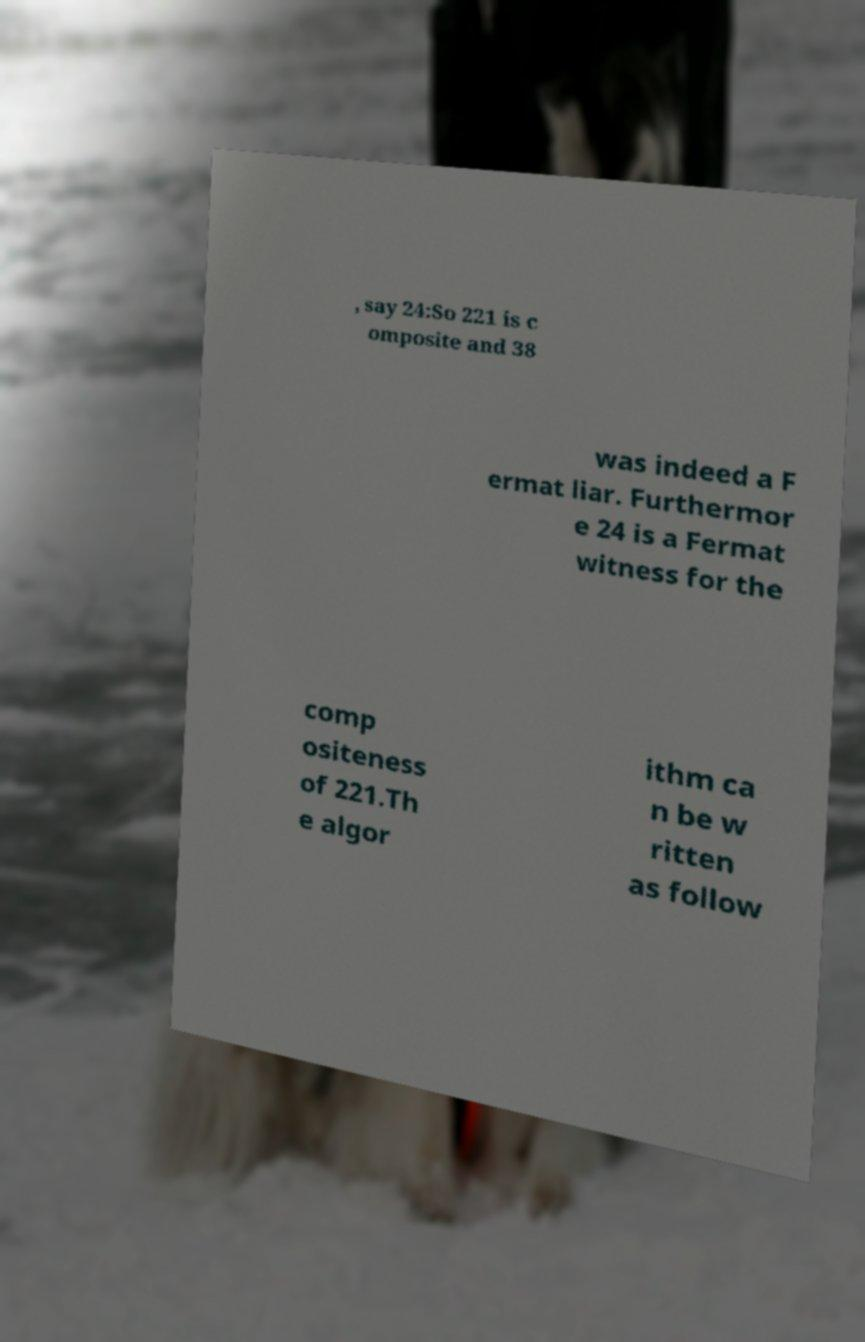Could you extract and type out the text from this image? , say 24:So 221 is c omposite and 38 was indeed a F ermat liar. Furthermor e 24 is a Fermat witness for the comp ositeness of 221.Th e algor ithm ca n be w ritten as follow 